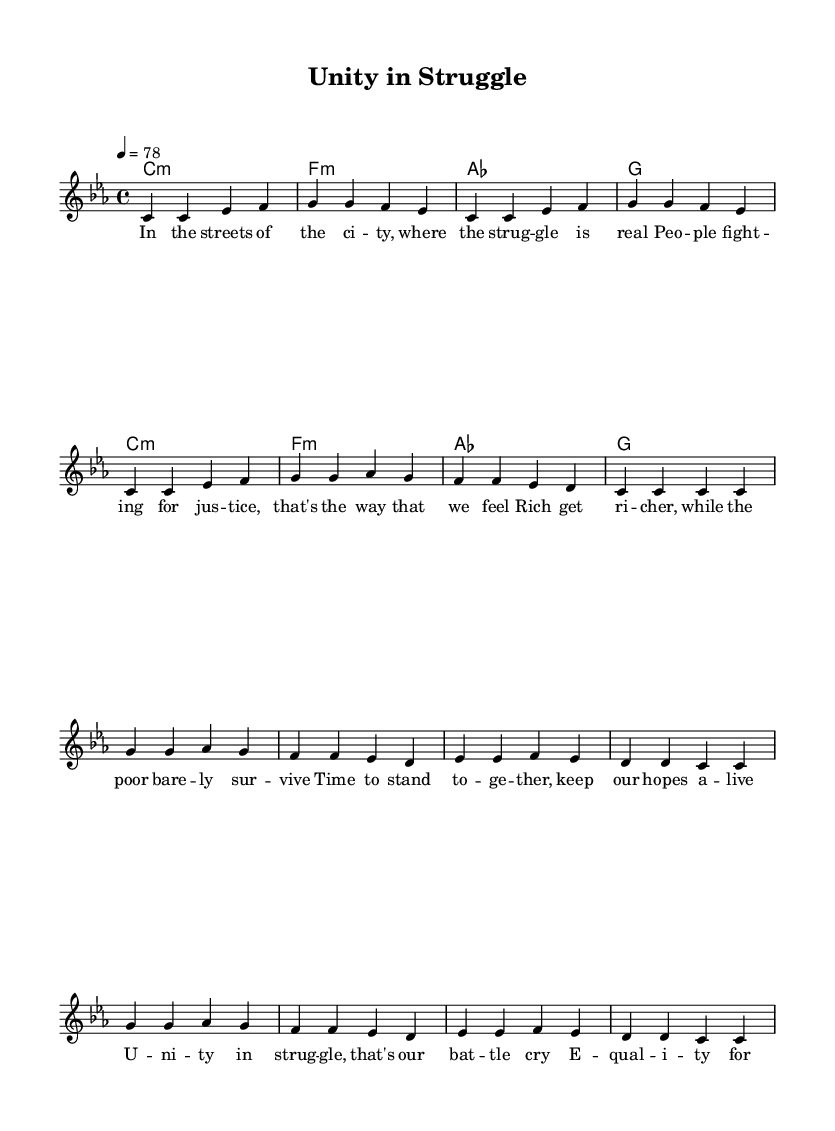What is the key signature of this music? The key signature is C minor, which has three flats: B flat, E flat, and A flat.
Answer: C minor What is the time signature of this piece? The time signature is 4/4, indicating four beats per measure and that a quarter note receives one beat.
Answer: 4/4 What is the tempo marking for this piece? The tempo marking states that the piece should be played at a speed of 78 beats per minute, which is indicated by the tempo notation.
Answer: 78 How many measures are in the verse section? The verse section contains 8 measures, as counted from the vertical lines indicating each measure space in the music.
Answer: 8 What thematic element is represented in the lyrics of this reggae anthem? The lyrics discuss social justice and unity, reflecting the common themes in reggae music focused on addressing social issues and inequality.
Answer: Social justice How does the chorus reinforce the message of the song? The chorus emphasizes unity and equality, urging collective action and resilience, which are core messages of socially conscious reggae anthems.
Answer: Unity and equality Which chord appears first in the harmonic progression? The first chord in the harmonic progression is C minor, as shown at the beginning of the score before the subsequent chords are listed.
Answer: C minor 